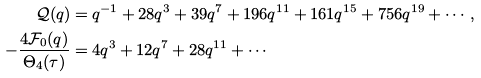Convert formula to latex. <formula><loc_0><loc_0><loc_500><loc_500>\mathcal { Q } ( q ) & = q ^ { - 1 } + 2 8 q ^ { 3 } + 3 9 q ^ { 7 } + 1 9 6 q ^ { 1 1 } + 1 6 1 q ^ { 1 5 } + 7 5 6 q ^ { 1 9 } + \cdots , \\ - \frac { 4 \mathcal { F } _ { 0 } ( q ) } { \Theta _ { 4 } ( \tau ) } & = 4 q ^ { 3 } + 1 2 q ^ { 7 } + 2 8 q ^ { 1 1 } + \cdots</formula> 